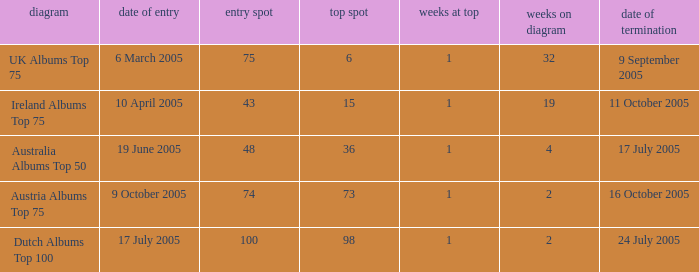What is the exit date for the Dutch Albums Top 100 Chart? 24 July 2005. 